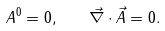<formula> <loc_0><loc_0><loc_500><loc_500>A ^ { 0 } = 0 , \quad \vec { \nabla } \cdot \vec { A } = 0 .</formula> 